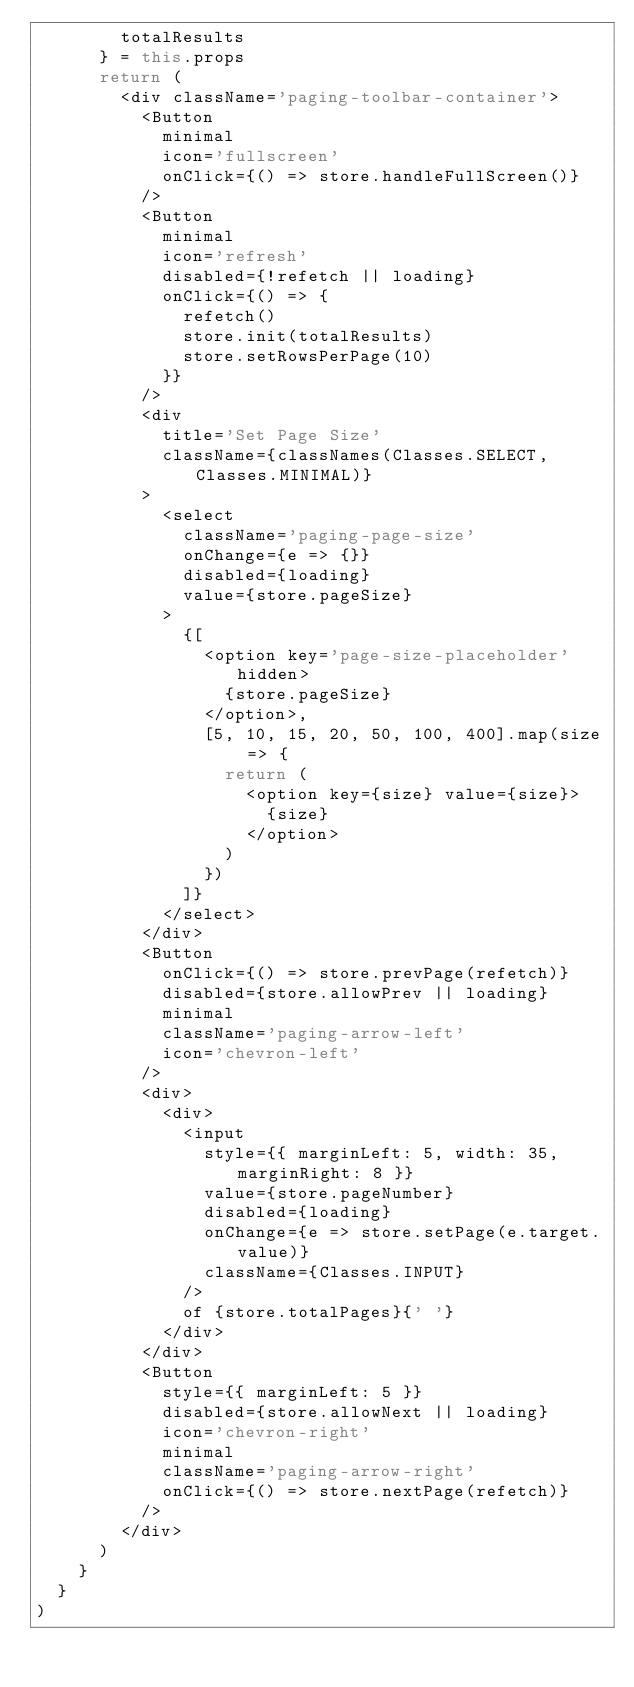Convert code to text. <code><loc_0><loc_0><loc_500><loc_500><_JavaScript_>        totalResults
      } = this.props
      return (
        <div className='paging-toolbar-container'>
          <Button
            minimal
            icon='fullscreen'
            onClick={() => store.handleFullScreen()}
          />
          <Button
            minimal
            icon='refresh'
            disabled={!refetch || loading}
            onClick={() => {
              refetch()
              store.init(totalResults)
              store.setRowsPerPage(10)
            }}
          />
          <div
            title='Set Page Size'
            className={classNames(Classes.SELECT, Classes.MINIMAL)}
          >
            <select
              className='paging-page-size'
              onChange={e => {}}
              disabled={loading}
              value={store.pageSize}
            >
              {[
                <option key='page-size-placeholder' hidden>
                  {store.pageSize}
                </option>,
                [5, 10, 15, 20, 50, 100, 400].map(size => {
                  return (
                    <option key={size} value={size}>
                      {size}
                    </option>
                  )
                })
              ]}
            </select>
          </div>
          <Button
            onClick={() => store.prevPage(refetch)}
            disabled={store.allowPrev || loading}
            minimal
            className='paging-arrow-left'
            icon='chevron-left'
          />
          <div>
            <div>
              <input
                style={{ marginLeft: 5, width: 35, marginRight: 8 }}
                value={store.pageNumber}
                disabled={loading}
                onChange={e => store.setPage(e.target.value)}
                className={Classes.INPUT}
              />
              of {store.totalPages}{' '}
            </div>
          </div>
          <Button
            style={{ marginLeft: 5 }}
            disabled={store.allowNext || loading}
            icon='chevron-right'
            minimal
            className='paging-arrow-right'
            onClick={() => store.nextPage(refetch)}
          />
        </div>
      )
    }
  }
)
</code> 